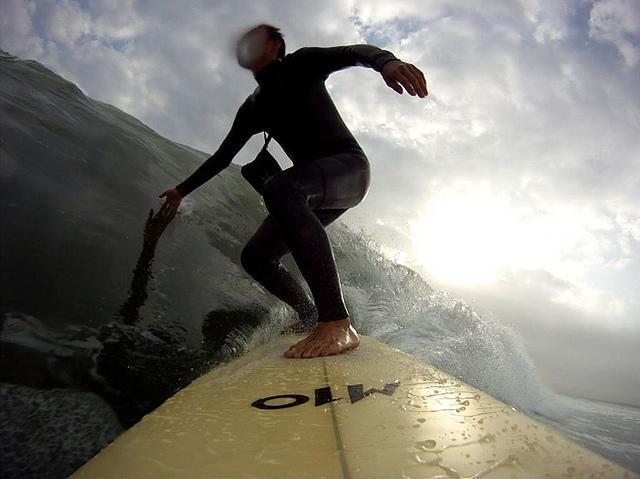How many red double decker buses are in the image?
Give a very brief answer. 0. 